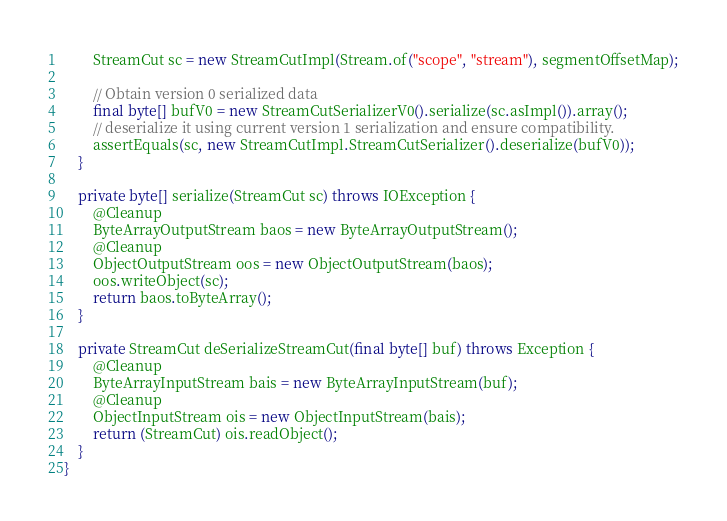<code> <loc_0><loc_0><loc_500><loc_500><_Java_>        StreamCut sc = new StreamCutImpl(Stream.of("scope", "stream"), segmentOffsetMap);

        // Obtain version 0 serialized data
        final byte[] bufV0 = new StreamCutSerializerV0().serialize(sc.asImpl()).array();
        // deserialize it using current version 1 serialization and ensure compatibility.
        assertEquals(sc, new StreamCutImpl.StreamCutSerializer().deserialize(bufV0));
    }

    private byte[] serialize(StreamCut sc) throws IOException {
        @Cleanup
        ByteArrayOutputStream baos = new ByteArrayOutputStream();
        @Cleanup
        ObjectOutputStream oos = new ObjectOutputStream(baos);
        oos.writeObject(sc);
        return baos.toByteArray();
    }

    private StreamCut deSerializeStreamCut(final byte[] buf) throws Exception {
        @Cleanup
        ByteArrayInputStream bais = new ByteArrayInputStream(buf);
        @Cleanup
        ObjectInputStream ois = new ObjectInputStream(bais);
        return (StreamCut) ois.readObject();
    }
}
</code> 